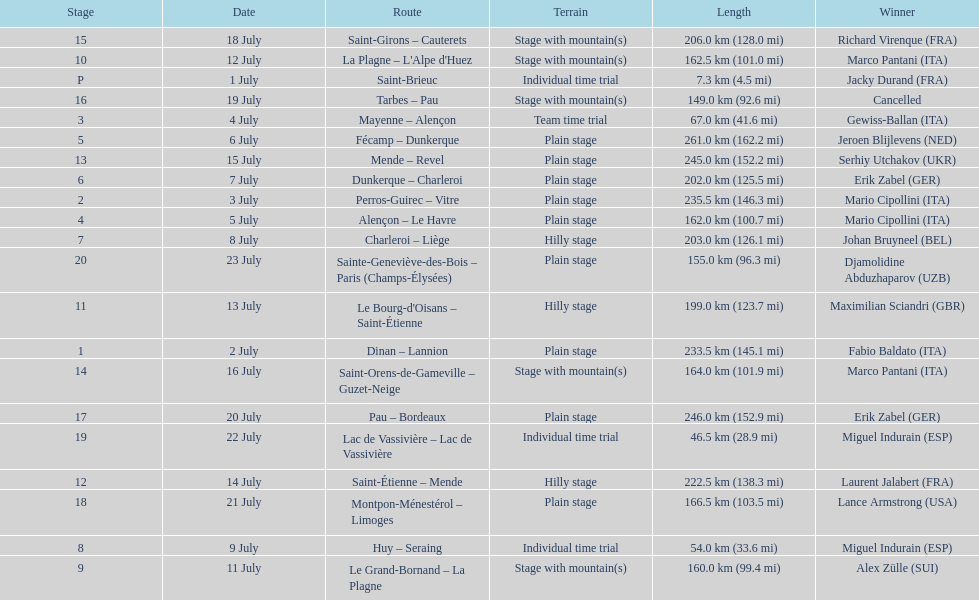How many consecutive km were raced on july 8th? 203.0 km (126.1 mi). 